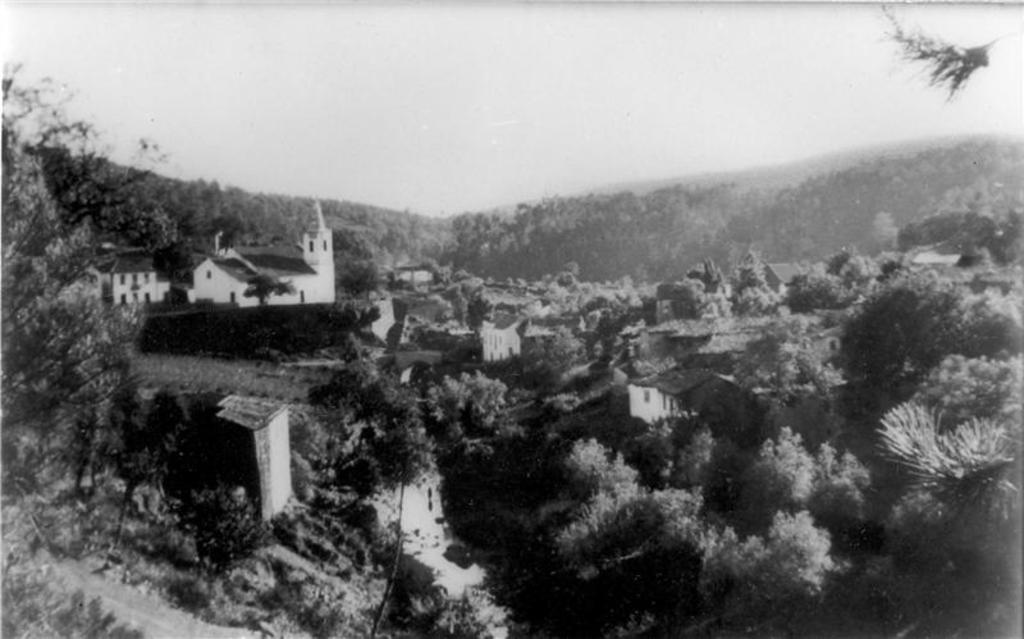Describe this image in one or two sentences. In this image there are trees, buildings. At the top of the image there is sky. 